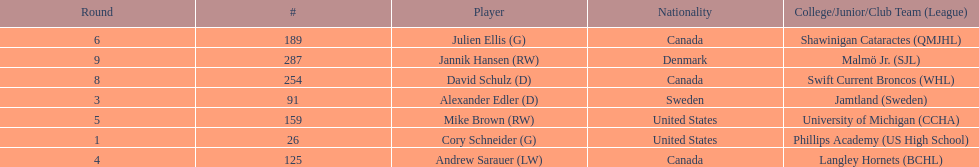How many goalies drafted? 2. 